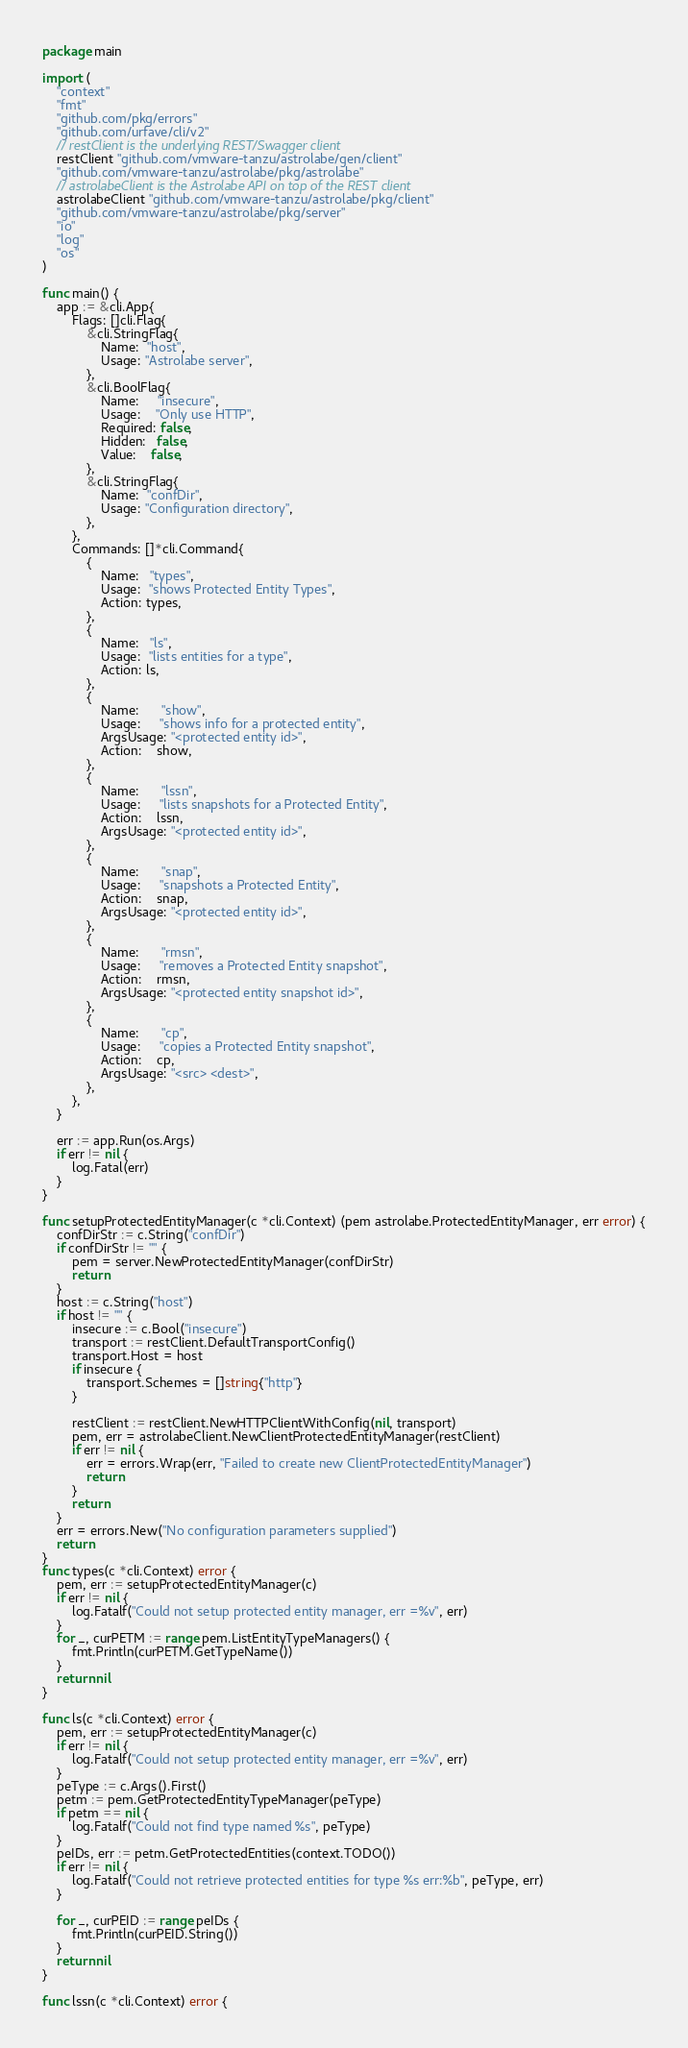<code> <loc_0><loc_0><loc_500><loc_500><_Go_>package main

import (
	"context"
	"fmt"
	"github.com/pkg/errors"
	"github.com/urfave/cli/v2"
	// restClient is the underlying REST/Swagger client
	restClient "github.com/vmware-tanzu/astrolabe/gen/client"
	"github.com/vmware-tanzu/astrolabe/pkg/astrolabe"
	// astrolabeClient is the Astrolabe API on top of the REST client
	astrolabeClient "github.com/vmware-tanzu/astrolabe/pkg/client"
	"github.com/vmware-tanzu/astrolabe/pkg/server"
	"io"
	"log"
	"os"
)

func main() {
	app := &cli.App{
		Flags: []cli.Flag{
			&cli.StringFlag{
				Name:  "host",
				Usage: "Astrolabe server",
			},
			&cli.BoolFlag{
				Name:     "insecure",
				Usage:    "Only use HTTP",
				Required: false,
				Hidden:   false,
				Value:    false,
			},
			&cli.StringFlag{
				Name:  "confDir",
				Usage: "Configuration directory",
			},
		},
		Commands: []*cli.Command{
			{
				Name:   "types",
				Usage:  "shows Protected Entity Types",
				Action: types,
			},
			{
				Name:   "ls",
				Usage:  "lists entities for a type",
				Action: ls,
			},
			{
				Name:      "show",
				Usage:     "shows info for a protected entity",
				ArgsUsage: "<protected entity id>",
				Action:    show,
			},
			{
				Name:      "lssn",
				Usage:     "lists snapshots for a Protected Entity",
				Action:    lssn,
				ArgsUsage: "<protected entity id>",
			},
			{
				Name:      "snap",
				Usage:     "snapshots a Protected Entity",
				Action:    snap,
				ArgsUsage: "<protected entity id>",
			},
			{
				Name:      "rmsn",
				Usage:     "removes a Protected Entity snapshot",
				Action:    rmsn,
				ArgsUsage: "<protected entity snapshot id>",
			},
			{
				Name:      "cp",
				Usage:     "copies a Protected Entity snapshot",
				Action:    cp,
				ArgsUsage: "<src> <dest>",
			},
		},
	}

	err := app.Run(os.Args)
	if err != nil {
		log.Fatal(err)
	}
}

func setupProtectedEntityManager(c *cli.Context) (pem astrolabe.ProtectedEntityManager, err error) {
	confDirStr := c.String("confDir")
	if confDirStr != "" {
		pem = server.NewProtectedEntityManager(confDirStr)
		return
	}
	host := c.String("host")
	if host != "" {
		insecure := c.Bool("insecure")
		transport := restClient.DefaultTransportConfig()
		transport.Host = host
		if insecure {
			transport.Schemes = []string{"http"}
		}

		restClient := restClient.NewHTTPClientWithConfig(nil, transport)
		pem, err = astrolabeClient.NewClientProtectedEntityManager(restClient)
		if err != nil {
			err = errors.Wrap(err, "Failed to create new ClientProtectedEntityManager")
			return
		}
		return
	}
	err = errors.New("No configuration parameters supplied")
	return
}
func types(c *cli.Context) error {
	pem, err := setupProtectedEntityManager(c)
	if err != nil {
		log.Fatalf("Could not setup protected entity manager, err =%v", err)
	}
	for _, curPETM := range pem.ListEntityTypeManagers() {
		fmt.Println(curPETM.GetTypeName())
	}
	return nil
}

func ls(c *cli.Context) error {
	pem, err := setupProtectedEntityManager(c)
	if err != nil {
		log.Fatalf("Could not setup protected entity manager, err =%v", err)
	}
	peType := c.Args().First()
	petm := pem.GetProtectedEntityTypeManager(peType)
	if petm == nil {
		log.Fatalf("Could not find type named %s", peType)
	}
	peIDs, err := petm.GetProtectedEntities(context.TODO())
	if err != nil {
		log.Fatalf("Could not retrieve protected entities for type %s err:%b", peType, err)
	}

	for _, curPEID := range peIDs {
		fmt.Println(curPEID.String())
	}
	return nil
}

func lssn(c *cli.Context) error {</code> 